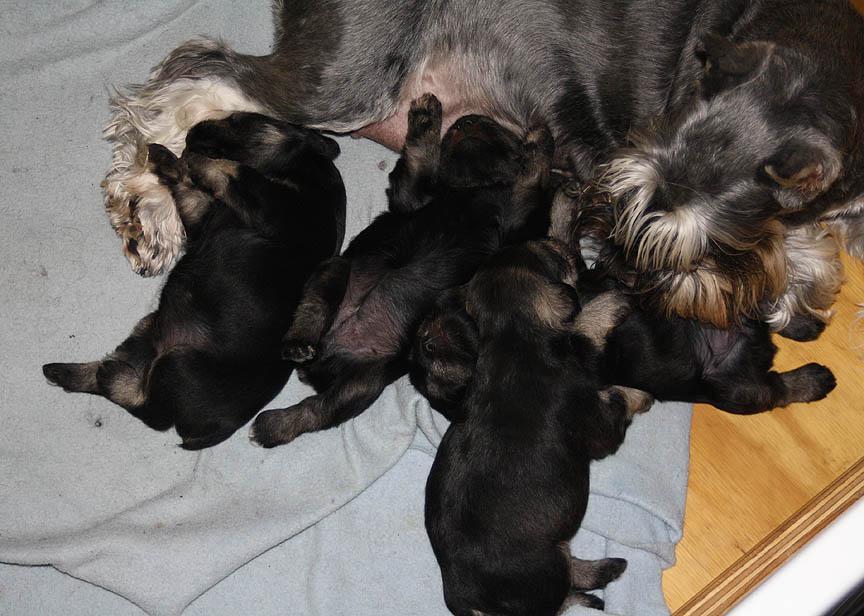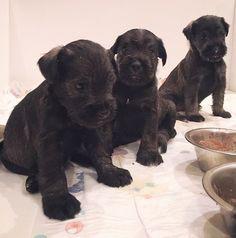The first image is the image on the left, the second image is the image on the right. Evaluate the accuracy of this statement regarding the images: "At least one image in the set features 4 or more puppies, laying with their mother.". Is it true? Answer yes or no. Yes. The first image is the image on the left, the second image is the image on the right. Considering the images on both sides, is "There are four or more puppies sleeping together in each image" valid? Answer yes or no. No. 